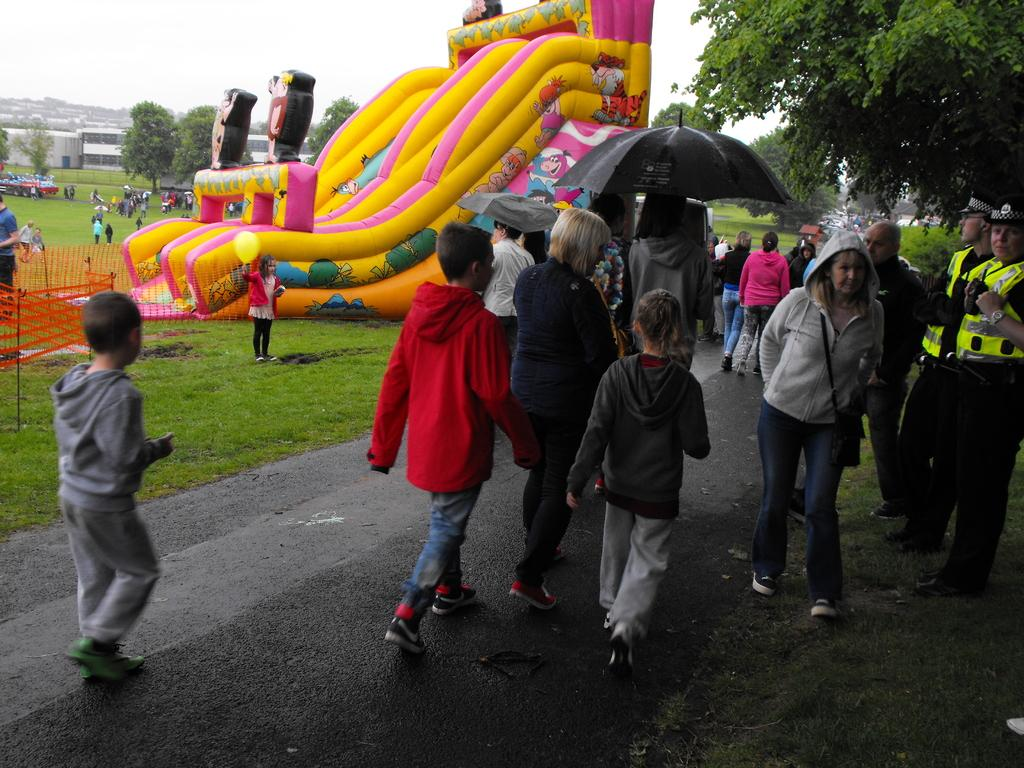How many people can be seen in the image? There are people in the image, but the exact number is not specified. What type of structure is present in the image? There is fencing in the image. What type of recreational equipment is visible in the image? There is a bouncy castle in the image. What type of vegetation can be seen in the image? There are plants and trees in the image. What type of buildings are present in the image? There are houses in the image. What is visible in the sky in the image? The sky is visible in the image. Can you see a receipt in the image? There is no mention of a receipt in the image, so it cannot be seen. Is there a judge present in the image? There is no mention of a judge in the image, so it cannot be seen. 